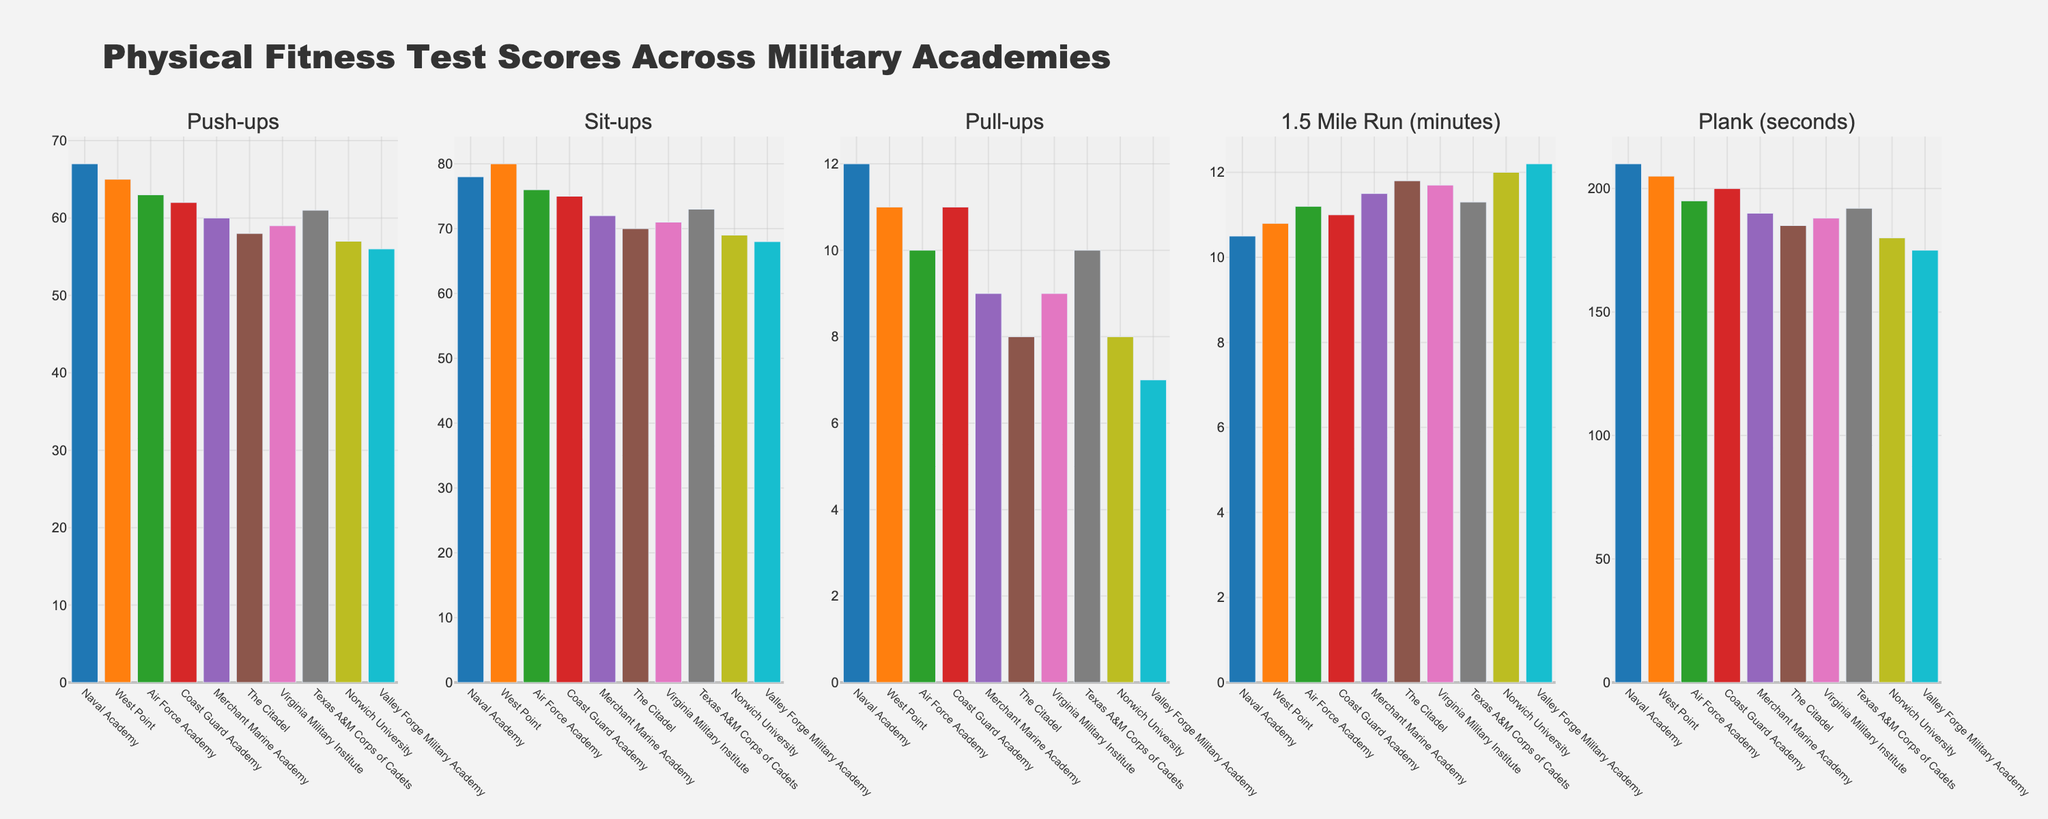What academy has the best average score across all exercises? First, sum the scores for each exercise of every academy, then divide by the number of exercises (5). The Naval Academy has the highest average with a sum of (67 + 78 + 12 + 10.5 + 210) = 377.5, so the average is 377.5 / 5 = 75.5.
Answer: Naval Academy Which academy has the lowest number of pull-ups? Check the values of pull-ups for each academy, and Norwich University and Valley Forge Military Academy have the lowest with a value of 7.
Answer: Norwich University, Valley Forge Military Academy Are there any academies that excel in push-ups but have poor performance in the 1.5 Mile Run? Compare the values of push-ups and 1.5 Mile Run across academies. Naval Academy excels in push-ups with 67 but performs relatively well in the 1.5 Mile Run with 10.5 minutes. However, no academy has a very high push-up score while being poor in the run.
Answer: No Which exercise shows the least variance in scores across academies? Calculate the variance for each exercise. Run through the values, and Plank (seconds) seems to have lower variance compared to other exercises. Scores vary from 175 to 210, which is relatively low.
Answer: Plank (seconds) Which two academies have the smallest difference in total scores across all exercises? Calculate the total scores for each academy and find the differences between them to identify the smallest. Merchant Marine Academy and Virginia Military Institute have totals of 342 and 343 respectively, with a difference of 1.
Answer: Merchant Marine Academy and Virginia Military Institute Which academy ranks third highest in sit-ups? Order the values of sit-ups from highest to lowest. West Point (80), Naval Academy (78), and the Air Force Academy (76) are the top three, so the Air Force Academy ranks third.
Answer: Air Force Academy Which exercise scores show an inverse relationship, where better performance in one means worse performance in the other? Examine the exercise pairs to check if an inverse relationship holds visually. Students with better scores in 'Push-ups' (higher is better) often perform slower (higher time) in the '1.5 Mile Run', showing an inverse relationship.
Answer: Push-ups and 1.5 Mile Run What is the average number of sit-ups across all academies? Add all the sit-ups values (78 + 80 + 76 + 75 + 72 + 70 + 71 + 73 + 69 + 68) = 732, and then divide by the number of academies (10). The average is 732 / 10 = 73.2.
Answer: 73.2 Does any academy have consistent performance (no significant highs or lows) across all exercises? Review the charts and observe if any academy's bars show minimal variation in height. West Point shows relatively consistent bars across all exercises without significant highs or lows.
Answer: West Point Which academy has the highest score in the plank (seconds) exercise? Check from the plotted values, the Naval Academy has the highest score with 210 seconds.
Answer: Naval Academy 